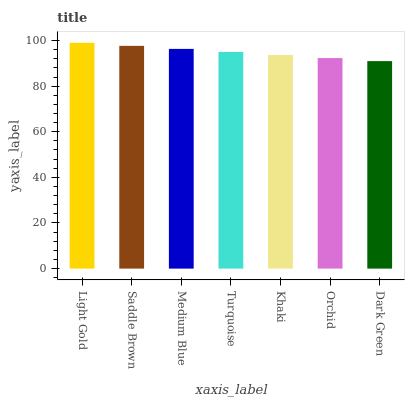Is Dark Green the minimum?
Answer yes or no. Yes. Is Light Gold the maximum?
Answer yes or no. Yes. Is Saddle Brown the minimum?
Answer yes or no. No. Is Saddle Brown the maximum?
Answer yes or no. No. Is Light Gold greater than Saddle Brown?
Answer yes or no. Yes. Is Saddle Brown less than Light Gold?
Answer yes or no. Yes. Is Saddle Brown greater than Light Gold?
Answer yes or no. No. Is Light Gold less than Saddle Brown?
Answer yes or no. No. Is Turquoise the high median?
Answer yes or no. Yes. Is Turquoise the low median?
Answer yes or no. Yes. Is Dark Green the high median?
Answer yes or no. No. Is Orchid the low median?
Answer yes or no. No. 